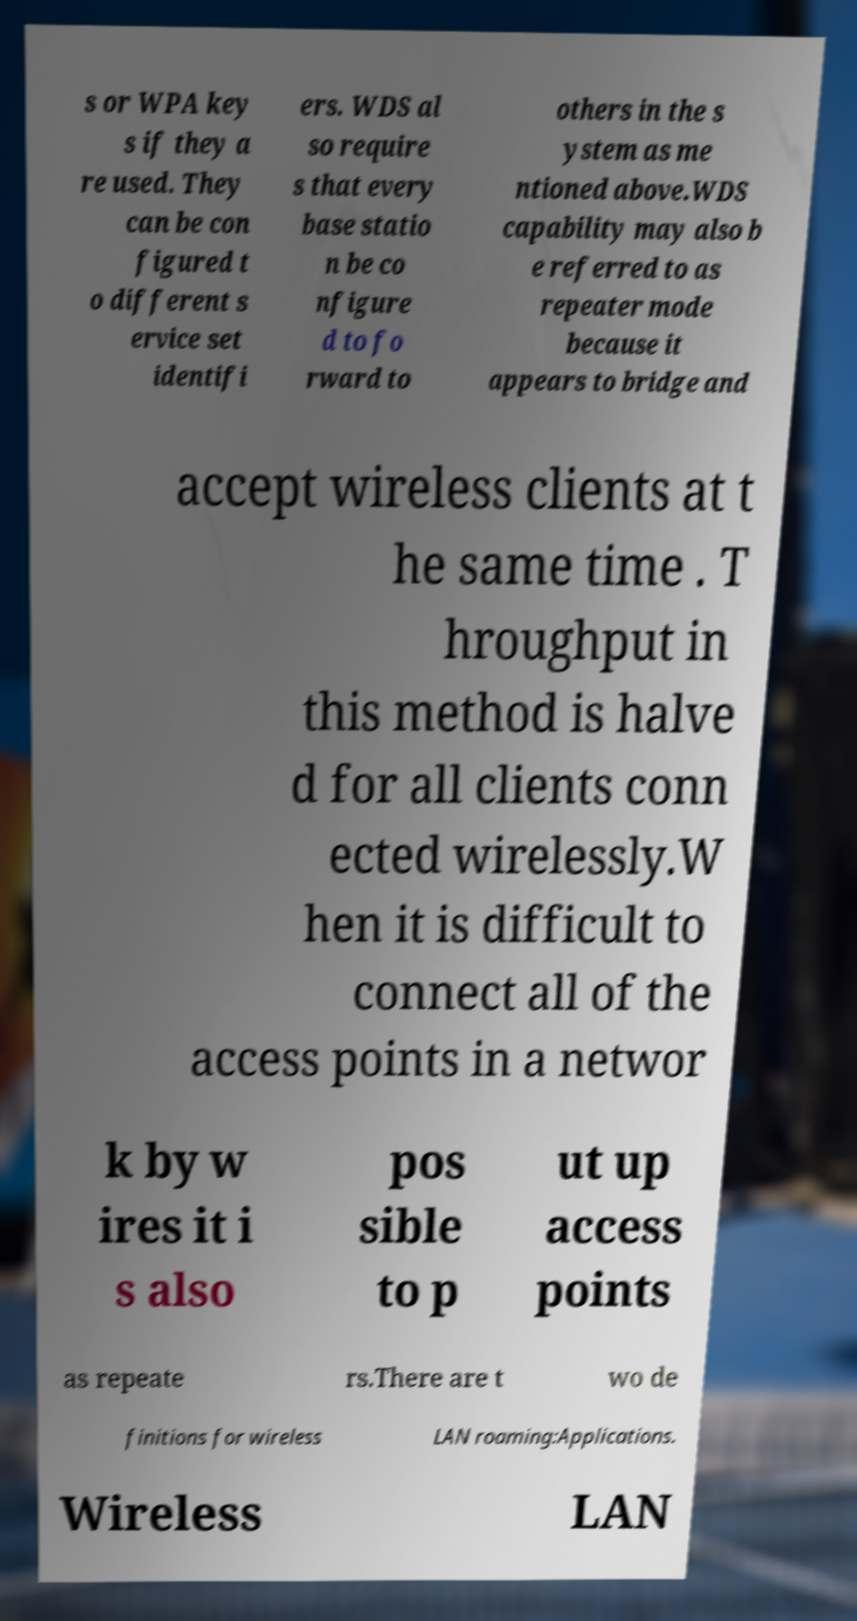Could you assist in decoding the text presented in this image and type it out clearly? s or WPA key s if they a re used. They can be con figured t o different s ervice set identifi ers. WDS al so require s that every base statio n be co nfigure d to fo rward to others in the s ystem as me ntioned above.WDS capability may also b e referred to as repeater mode because it appears to bridge and accept wireless clients at t he same time . T hroughput in this method is halve d for all clients conn ected wirelessly.W hen it is difficult to connect all of the access points in a networ k by w ires it i s also pos sible to p ut up access points as repeate rs.There are t wo de finitions for wireless LAN roaming:Applications. Wireless LAN 